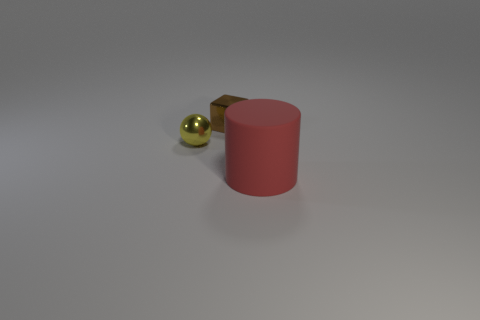Add 1 yellow shiny things. How many objects exist? 4 Subtract all cubes. How many objects are left? 2 Subtract 0 blue spheres. How many objects are left? 3 Subtract all spheres. Subtract all metallic cubes. How many objects are left? 1 Add 3 tiny shiny balls. How many tiny shiny balls are left? 4 Add 2 big green metallic spheres. How many big green metallic spheres exist? 2 